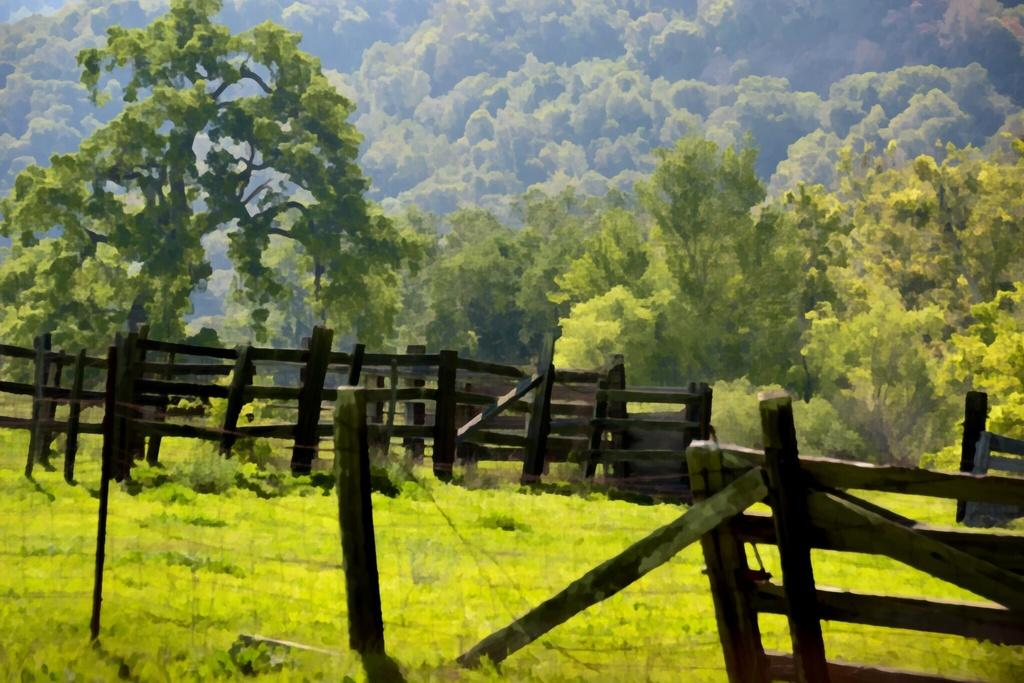What is located in the center of the image? There is a fence in the center of the image. What type of vegetation is at the bottom of the image? There is grass at the bottom of the image. What can be seen in the background of the image? There are trees in the background of the image. What type of brass instrument is being played during the event in the image? There is no brass instrument or event present in the image; it features a fence, grass, and trees. 